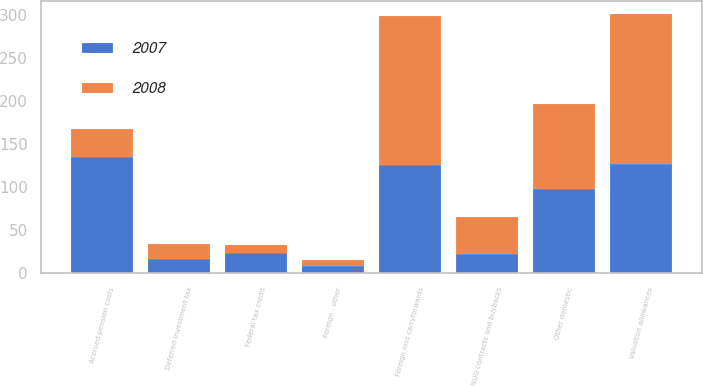Convert chart to OTSL. <chart><loc_0><loc_0><loc_500><loc_500><stacked_bar_chart><ecel><fcel>Deferred investment tax<fcel>NUG contracts and buybacks<fcel>Accrued pension costs<fcel>Federal tax credit<fcel>Foreign loss carryforwards<fcel>Foreign - other<fcel>Other domestic<fcel>Valuation allowances<nl><fcel>2007<fcel>16<fcel>22<fcel>135<fcel>23<fcel>126<fcel>9<fcel>98<fcel>127<nl><fcel>2008<fcel>18<fcel>43<fcel>32<fcel>10<fcel>173<fcel>6<fcel>99<fcel>174<nl></chart> 